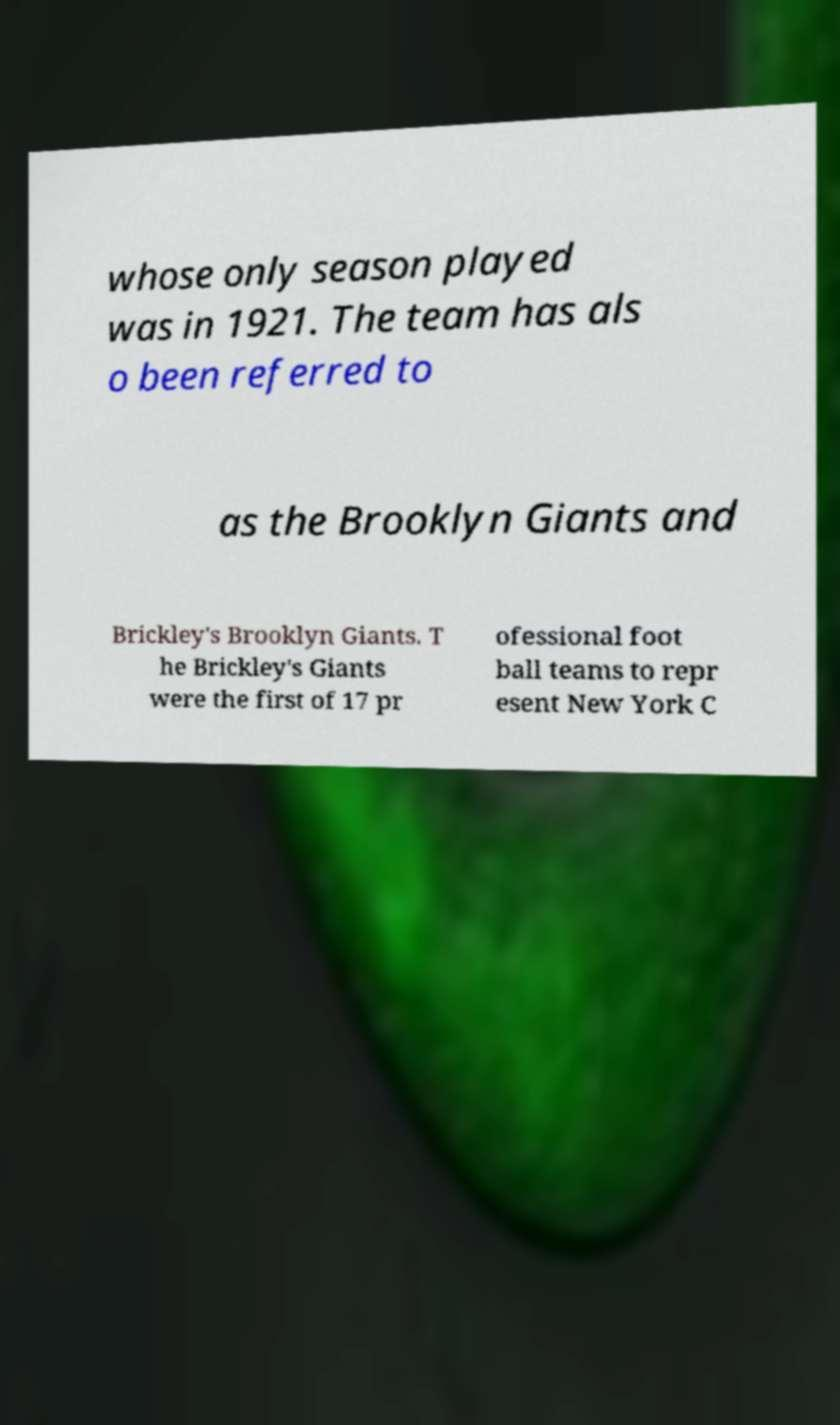Can you read and provide the text displayed in the image?This photo seems to have some interesting text. Can you extract and type it out for me? whose only season played was in 1921. The team has als o been referred to as the Brooklyn Giants and Brickley's Brooklyn Giants. T he Brickley's Giants were the first of 17 pr ofessional foot ball teams to repr esent New York C 